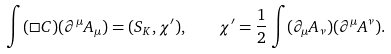<formula> <loc_0><loc_0><loc_500><loc_500>\int ( \Box C ) ( \partial ^ { \mu } A _ { \mu } ) = ( S _ { K } , \chi ^ { \prime } ) , \quad \chi ^ { \prime } = \frac { 1 } { 2 } \int ( \partial _ { \mu } A _ { \nu } ) ( \partial ^ { \mu } A ^ { \nu } ) .</formula> 